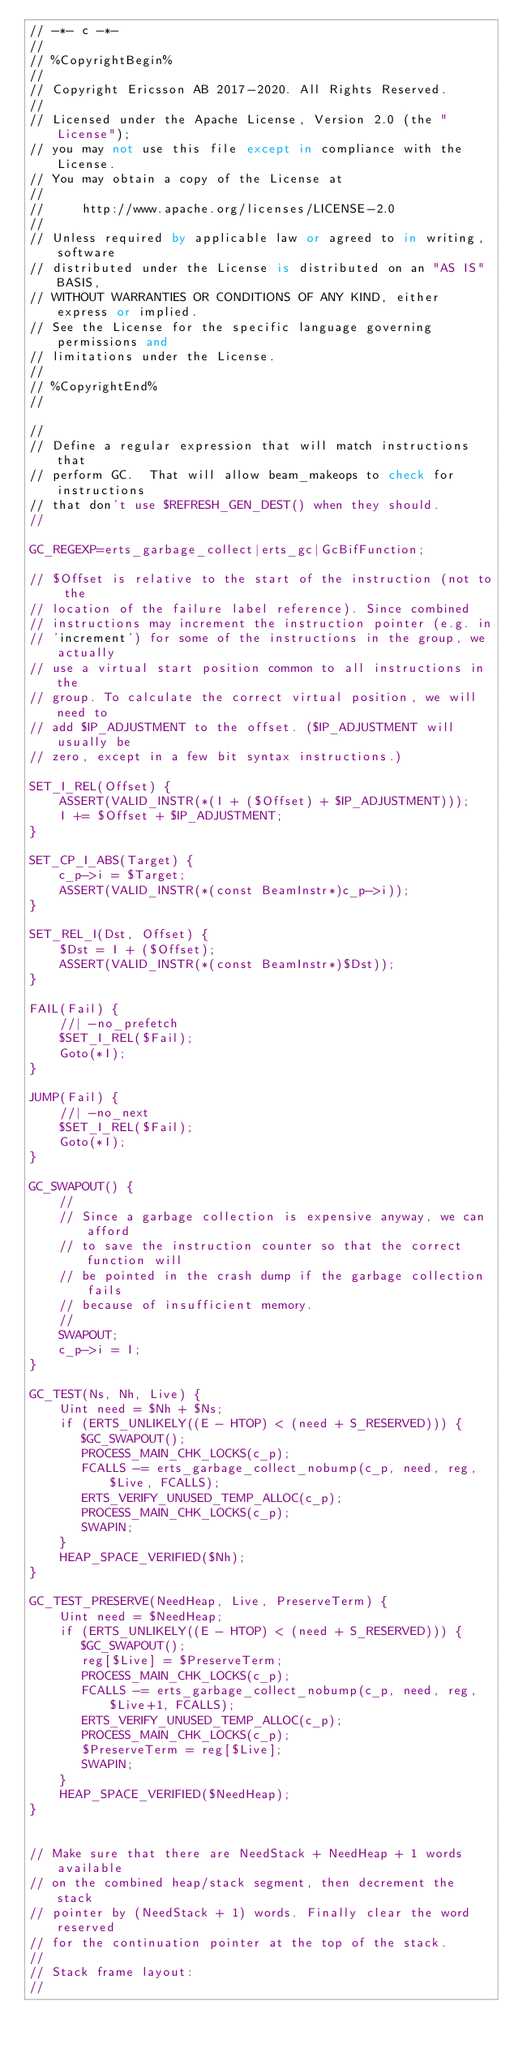<code> <loc_0><loc_0><loc_500><loc_500><_SQL_>// -*- c -*-
//
// %CopyrightBegin%
//
// Copyright Ericsson AB 2017-2020. All Rights Reserved.
//
// Licensed under the Apache License, Version 2.0 (the "License");
// you may not use this file except in compliance with the License.
// You may obtain a copy of the License at
//
//     http://www.apache.org/licenses/LICENSE-2.0
//
// Unless required by applicable law or agreed to in writing, software
// distributed under the License is distributed on an "AS IS" BASIS,
// WITHOUT WARRANTIES OR CONDITIONS OF ANY KIND, either express or implied.
// See the License for the specific language governing permissions and
// limitations under the License.
//
// %CopyrightEnd%
//

//
// Define a regular expression that will match instructions that
// perform GC.  That will allow beam_makeops to check for instructions
// that don't use $REFRESH_GEN_DEST() when they should.
//

GC_REGEXP=erts_garbage_collect|erts_gc|GcBifFunction;

// $Offset is relative to the start of the instruction (not to the
// location of the failure label reference). Since combined
// instructions may increment the instruction pointer (e.g. in
// 'increment') for some of the instructions in the group, we actually
// use a virtual start position common to all instructions in the
// group. To calculate the correct virtual position, we will need to
// add $IP_ADJUSTMENT to the offset. ($IP_ADJUSTMENT will usually be
// zero, except in a few bit syntax instructions.)

SET_I_REL(Offset) {
    ASSERT(VALID_INSTR(*(I + ($Offset) + $IP_ADJUSTMENT)));
    I += $Offset + $IP_ADJUSTMENT;
}

SET_CP_I_ABS(Target) {
    c_p->i = $Target;
    ASSERT(VALID_INSTR(*(const BeamInstr*)c_p->i));
}

SET_REL_I(Dst, Offset) {
    $Dst = I + ($Offset);
    ASSERT(VALID_INSTR(*(const BeamInstr*)$Dst));
}

FAIL(Fail) {
    //| -no_prefetch
    $SET_I_REL($Fail);
    Goto(*I);
}

JUMP(Fail) {
    //| -no_next
    $SET_I_REL($Fail);
    Goto(*I);
}

GC_SWAPOUT() {
    //
    // Since a garbage collection is expensive anyway, we can afford
    // to save the instruction counter so that the correct function will
    // be pointed in the crash dump if the garbage collection fails
    // because of insufficient memory.
    //
    SWAPOUT;
    c_p->i = I;
}

GC_TEST(Ns, Nh, Live) {
    Uint need = $Nh + $Ns;
    if (ERTS_UNLIKELY((E - HTOP) < (need + S_RESERVED))) {
       $GC_SWAPOUT();
       PROCESS_MAIN_CHK_LOCKS(c_p);
       FCALLS -= erts_garbage_collect_nobump(c_p, need, reg, $Live, FCALLS);
       ERTS_VERIFY_UNUSED_TEMP_ALLOC(c_p);
       PROCESS_MAIN_CHK_LOCKS(c_p);
       SWAPIN;
    }
    HEAP_SPACE_VERIFIED($Nh);
}

GC_TEST_PRESERVE(NeedHeap, Live, PreserveTerm) {
    Uint need = $NeedHeap;
    if (ERTS_UNLIKELY((E - HTOP) < (need + S_RESERVED))) {
       $GC_SWAPOUT();
       reg[$Live] = $PreserveTerm;
       PROCESS_MAIN_CHK_LOCKS(c_p);
       FCALLS -= erts_garbage_collect_nobump(c_p, need, reg, $Live+1, FCALLS);
       ERTS_VERIFY_UNUSED_TEMP_ALLOC(c_p);
       PROCESS_MAIN_CHK_LOCKS(c_p);
       $PreserveTerm = reg[$Live];
       SWAPIN;
    }
    HEAP_SPACE_VERIFIED($NeedHeap);
}


// Make sure that there are NeedStack + NeedHeap + 1 words available
// on the combined heap/stack segment, then decrement the stack
// pointer by (NeedStack + 1) words. Finally clear the word reserved
// for the continuation pointer at the top of the stack.
//
// Stack frame layout:
//</code> 